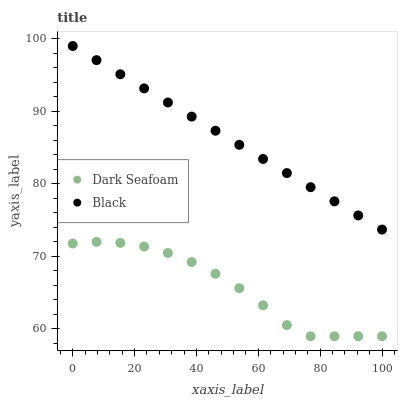Does Dark Seafoam have the minimum area under the curve?
Answer yes or no. Yes. Does Black have the maximum area under the curve?
Answer yes or no. Yes. Does Black have the minimum area under the curve?
Answer yes or no. No. Is Black the smoothest?
Answer yes or no. Yes. Is Dark Seafoam the roughest?
Answer yes or no. Yes. Is Black the roughest?
Answer yes or no. No. Does Dark Seafoam have the lowest value?
Answer yes or no. Yes. Does Black have the lowest value?
Answer yes or no. No. Does Black have the highest value?
Answer yes or no. Yes. Is Dark Seafoam less than Black?
Answer yes or no. Yes. Is Black greater than Dark Seafoam?
Answer yes or no. Yes. Does Dark Seafoam intersect Black?
Answer yes or no. No. 